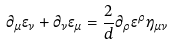<formula> <loc_0><loc_0><loc_500><loc_500>\partial _ { \mu } \epsilon _ { \nu } + \partial _ { \nu } \epsilon _ { \mu } = \frac { 2 } { d } \partial _ { \rho } \epsilon ^ { \rho } \eta _ { \mu \nu }</formula> 